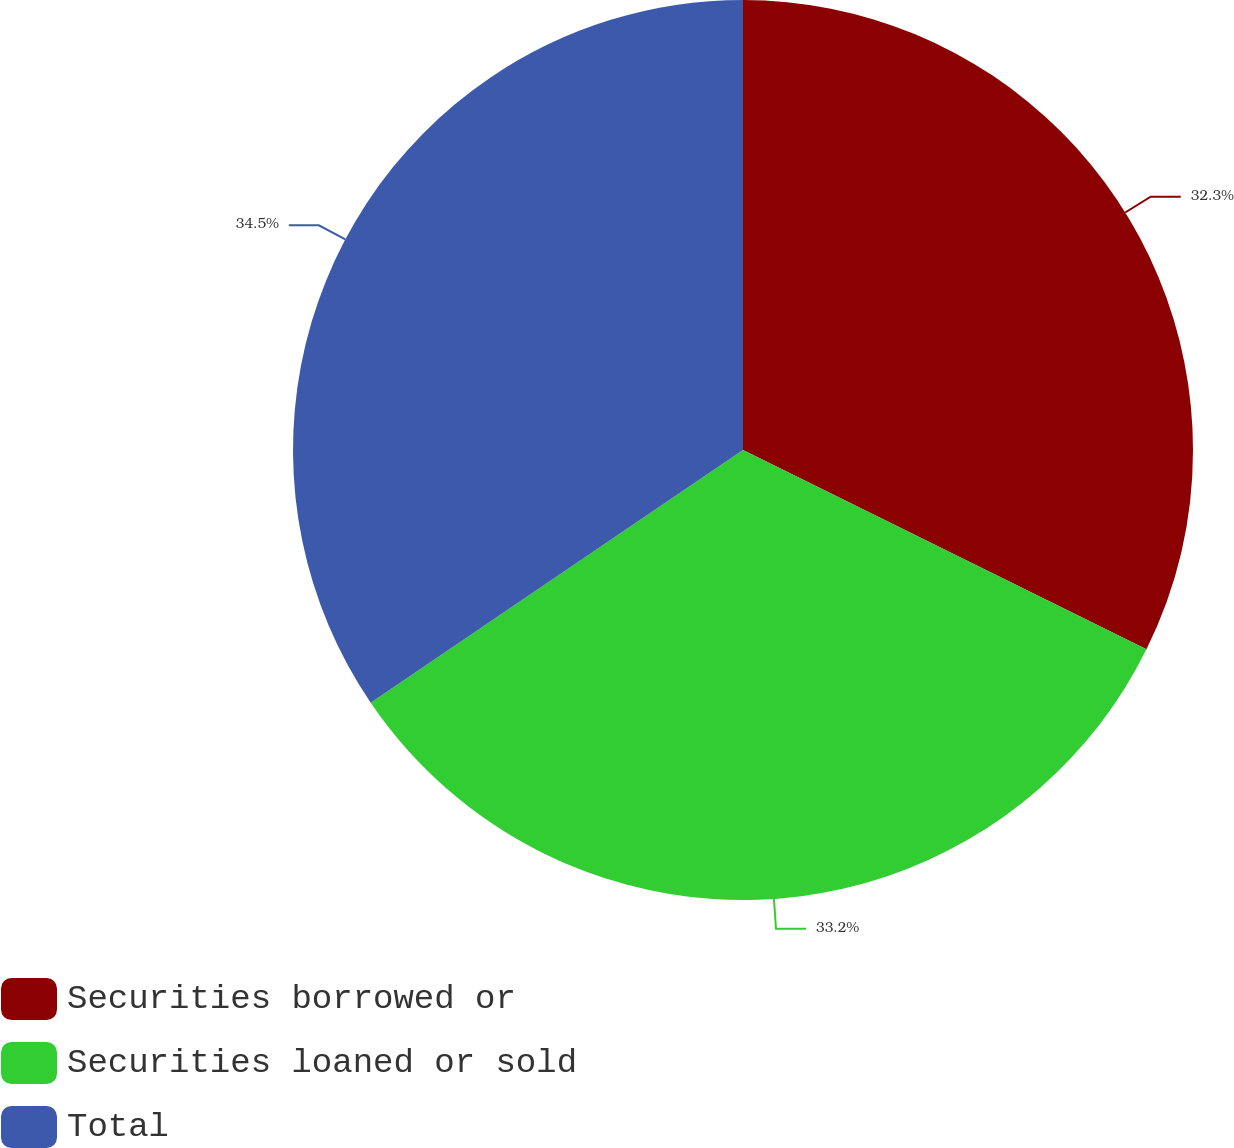Convert chart to OTSL. <chart><loc_0><loc_0><loc_500><loc_500><pie_chart><fcel>Securities borrowed or<fcel>Securities loaned or sold<fcel>Total<nl><fcel>32.3%<fcel>33.2%<fcel>34.49%<nl></chart> 